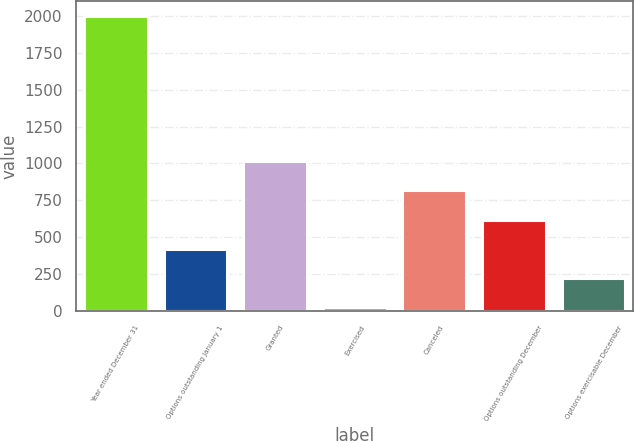<chart> <loc_0><loc_0><loc_500><loc_500><bar_chart><fcel>Year ended December 31<fcel>Options outstanding January 1<fcel>Granted<fcel>Exercised<fcel>Canceled<fcel>Options outstanding December<fcel>Options exercisable December<nl><fcel>2001<fcel>422.33<fcel>1014.34<fcel>27.65<fcel>817<fcel>619.66<fcel>224.99<nl></chart> 